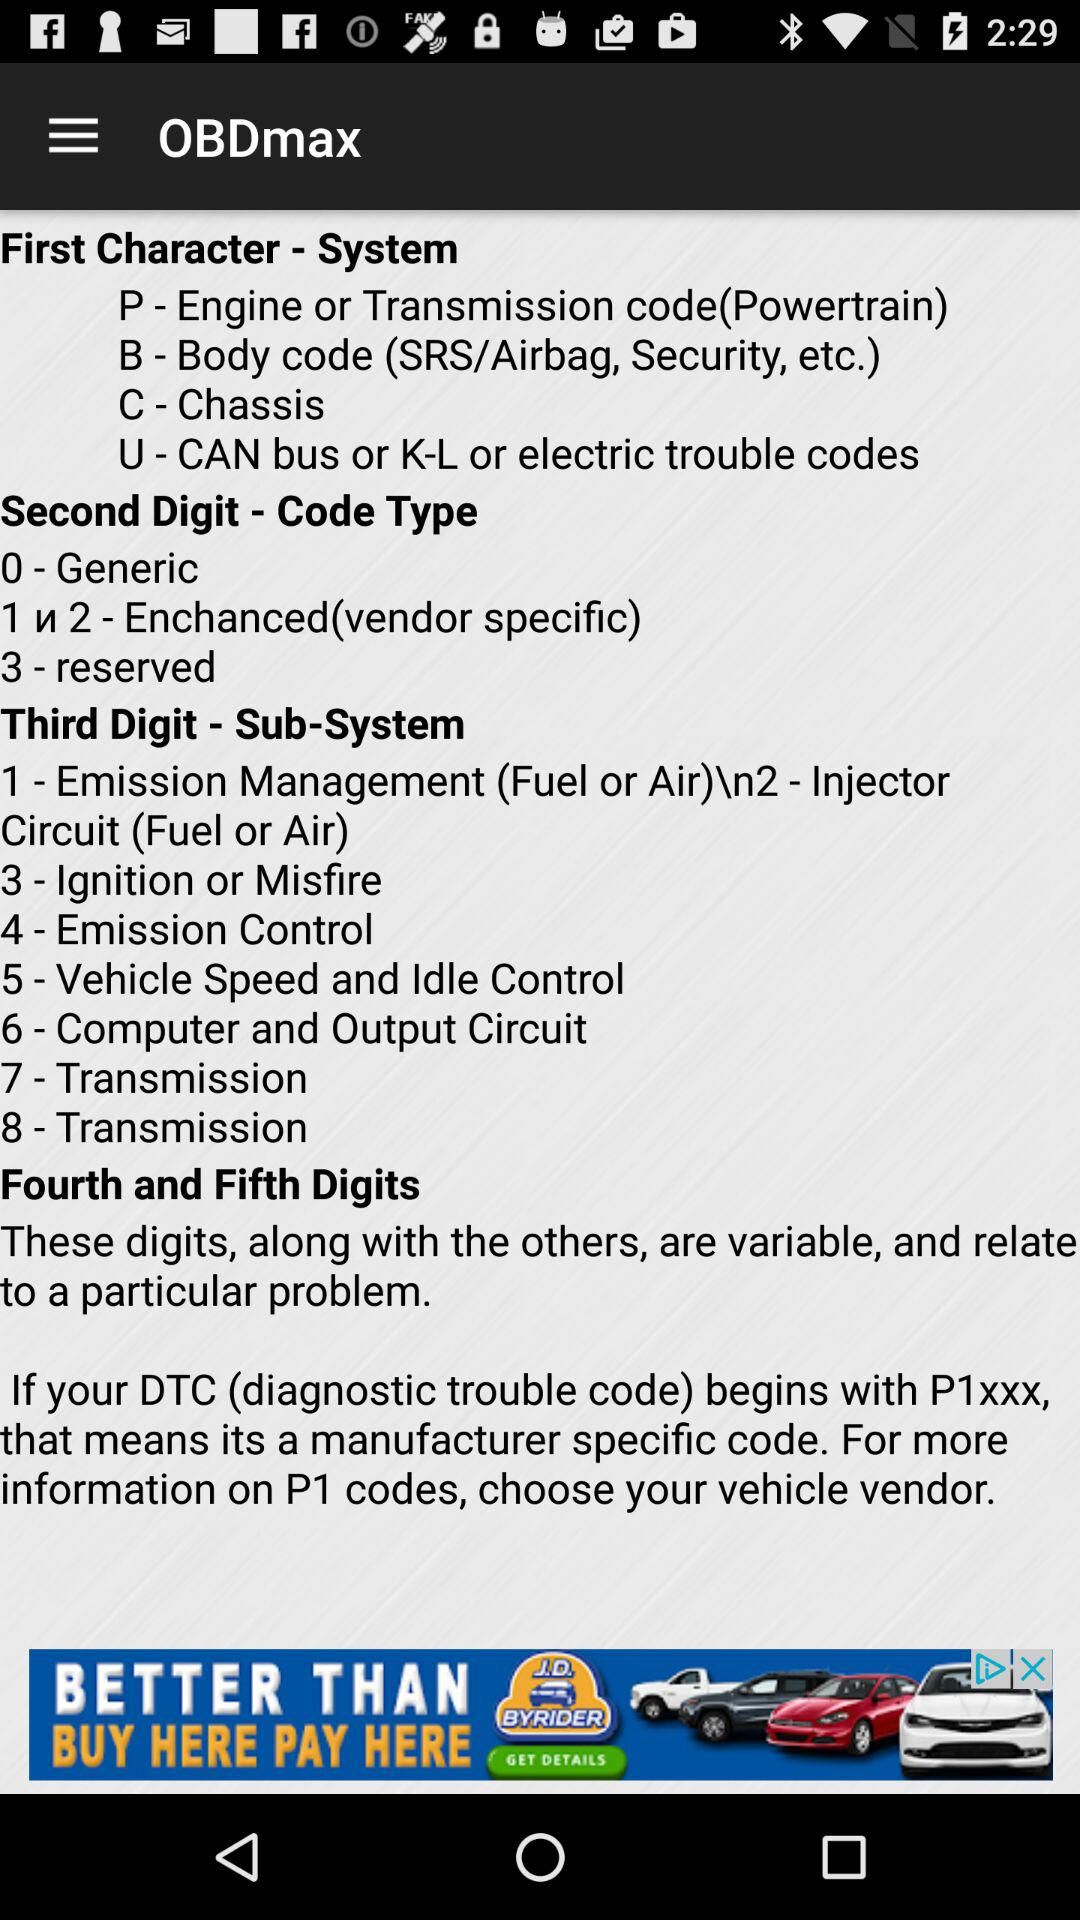What is the name of the application? The name of the application is "OBDmax". 